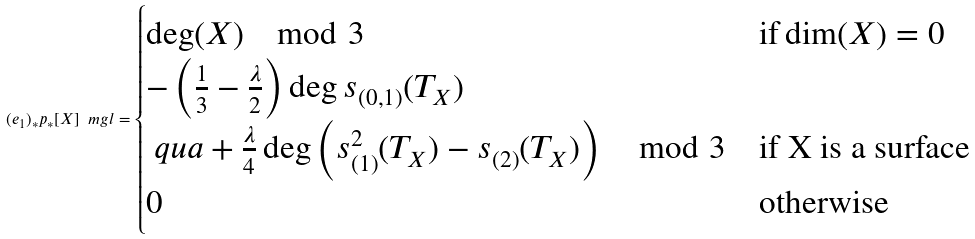Convert formula to latex. <formula><loc_0><loc_0><loc_500><loc_500>( e _ { 1 } ) _ { * } p _ { * } [ X ] _ { \ } m g l = \begin{cases} \deg ( X ) \mod 3 & \text {if} \dim ( X ) = 0 \\ - \left ( \frac { 1 } { 3 } - \frac { \lambda } { 2 } \right ) \deg s _ { ( 0 , 1 ) } ( T _ { X } ) \\ \ q u a + \frac { \lambda } { 4 } \deg \left ( s _ { ( 1 ) } ^ { 2 } ( T _ { X } ) - s _ { ( 2 ) } ( T _ { X } ) \right ) \mod 3 & \text {if X is a surface} \\ 0 & \text {otherwise} \end{cases}</formula> 